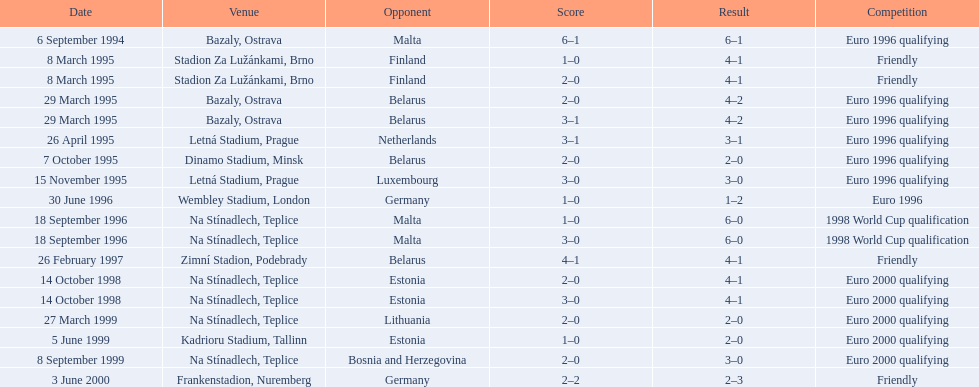List the opponents which are under the friendly competition. Finland, Belarus, Germany. 